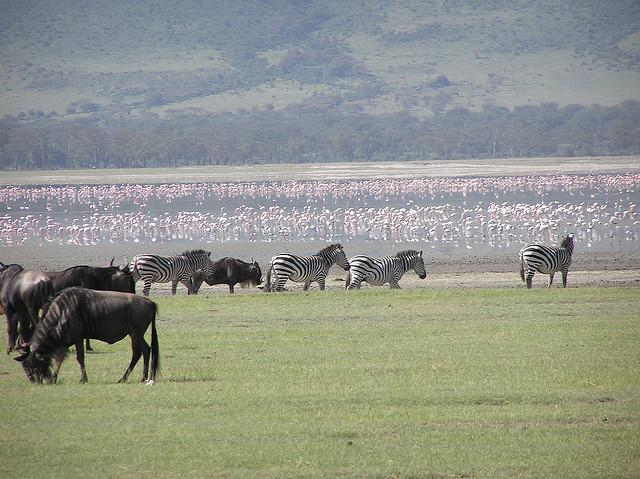Which animal is the weakest? Please explain your reasoning. flamingo. Flamingos are grazing near livestock. 